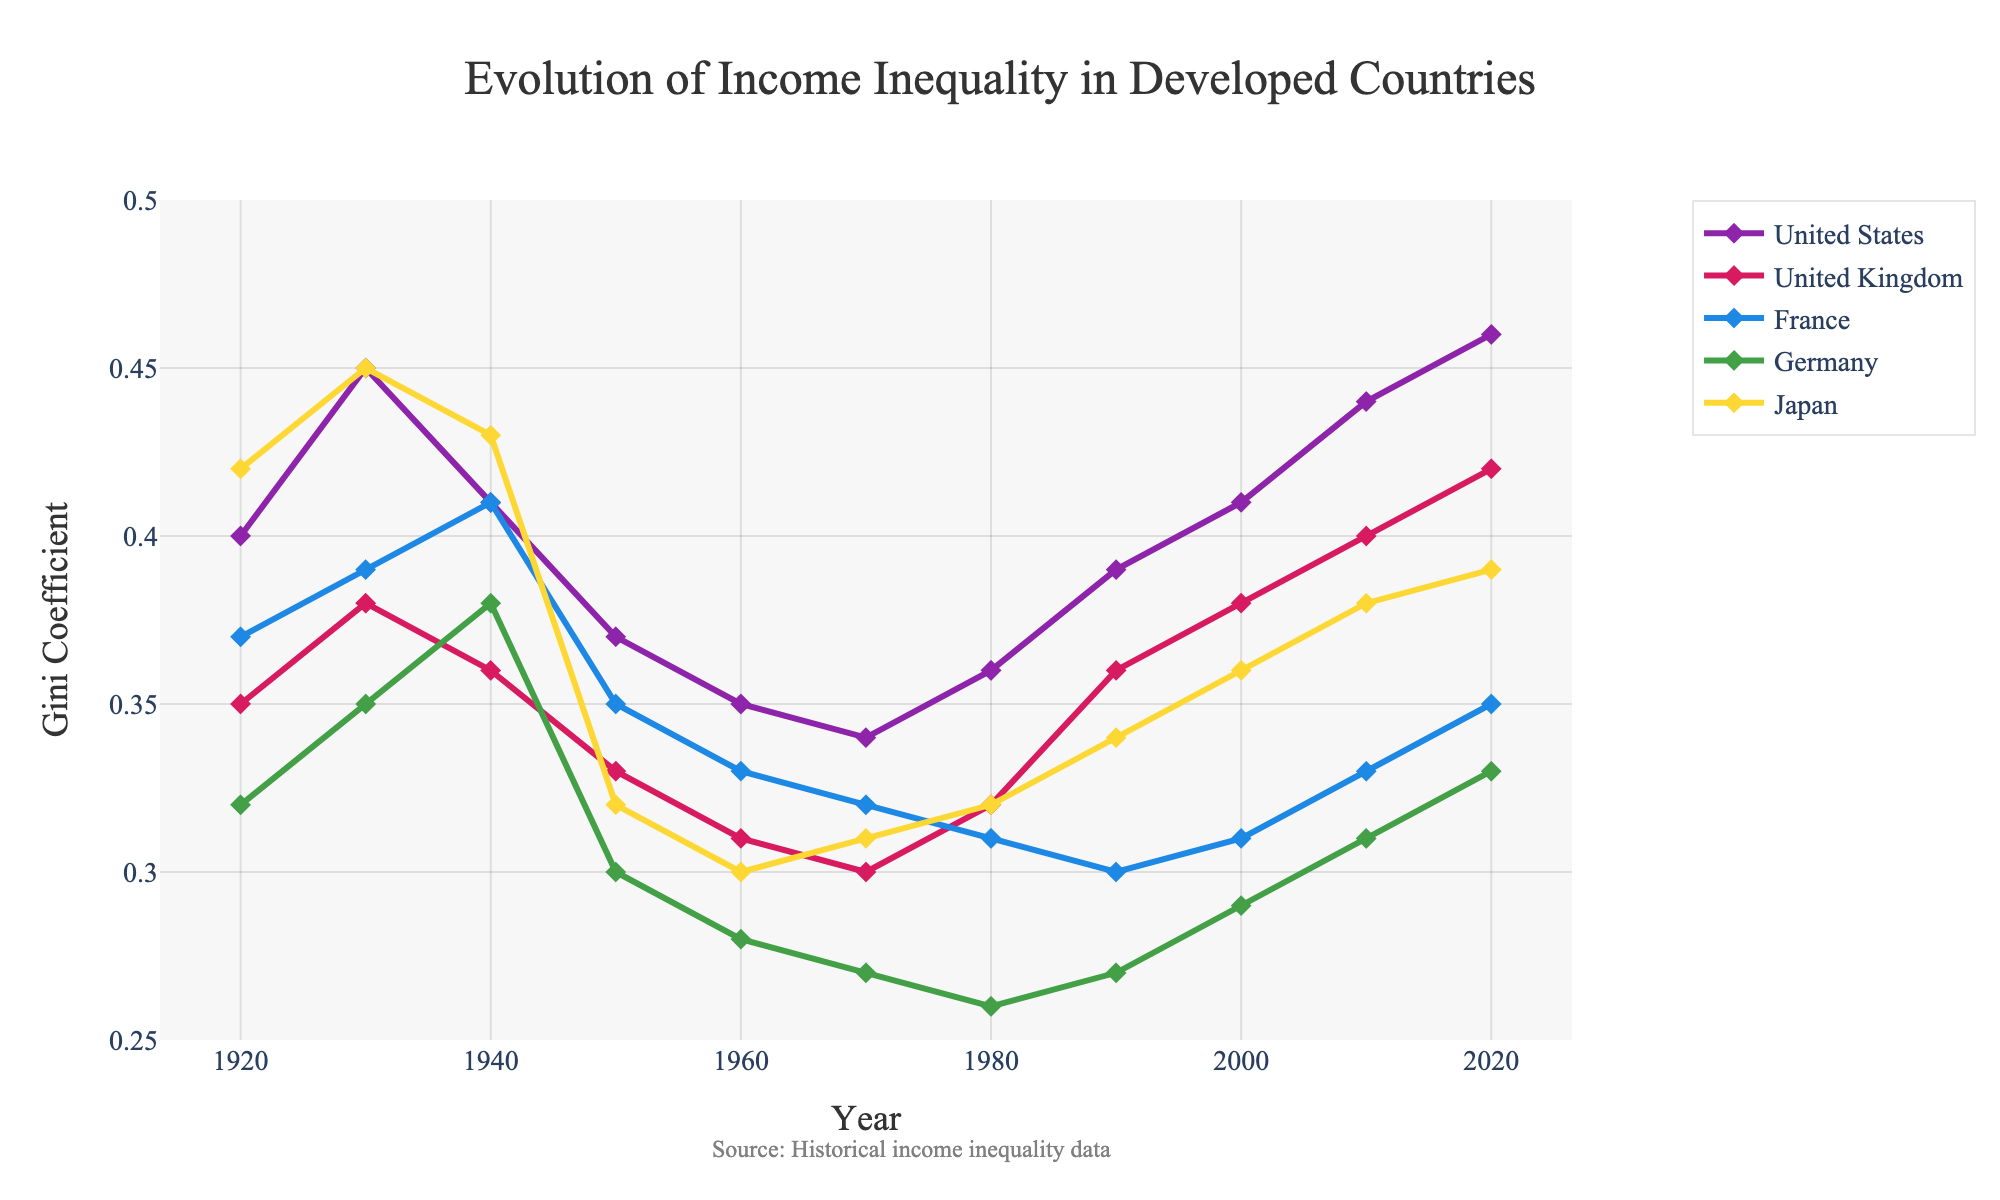what's the country with the highest Gini coefficient in the 1920s? Look for the highest value in the 1920 row. From the provided data, Japan has the highest Gini coefficient of 0.42 in 1920.
Answer: Japan which country showed the largest increase in Gini coefficient from 1950 to 2020? Calculate the difference between 2020 and 1950 for each country. The differences are: United States (+0.09), United Kingdom (+0.09), France (0), Germany (+0.03), Japan (+0.07). Both the United States and the United Kingdom showed the largest increase of 0.09.
Answer: United States and United Kingdom what year did Germany have the lowest Gini coefficient? Look across the Gini coefficient values specific to Germany in all years and identify the lowest one. The lowest value of 0.26 appears in 1980.
Answer: 1980 which country's Gini coefficient stayed the most stable (smallest range) over the century? Calculate the range (max-min) for each country over all years. The ranges are: United States (0.12), United Kingdom (0.12), France (0.11), Germany (0.11), Japan (0.15). France and Germany both have the smallest range of 0.11.
Answer: France and Germany between 1940 and 1950, which country saw the largest drop in Gini coefficient? Calculate the difference between 1940 and 1950 values for each country. The drops are: United States (-0.04), United Kingdom (-0.03), France (-0.06), Germany (-0.08), Japan (-0.11). Japan saw the largest drop of 0.11.
Answer: Japan did any country have a higher Gini coefficient in 1980 compared to 1970? if so, which? Compare the values of 1970 and 1980. Only the United States had a higher Gini coefficient in 1980 (0.36) compared to 1970 (0.34).
Answer: United States which country had the most significant fluctuation in Gini coefficient from 1920 to 2020? To determine the most significant fluctuation, look at the total change from 1920 to 2020, considering both increases and decreases. For all countries: United States (+0.06), United Kingdom (+0.07), France (-0.02), Germany (+0.01), Japan (-0.03). The United Kingdom saw the most significant fluctuation with +0.07.
Answer: United Kingdom what is the average Gini coefficient for France over the entire century? Calculate the average by summing France's values and dividing by the number of data points: (0.37 + 0.39 + 0.41 + 0.35 + 0.33 + 0.32 + 0.31 + 0.30 + 0.31 + 0.33 + 0.35) / 11 = 3.77 / 11 ≈ 0.34.
Answer: 0.34 in which decade did Japan experience the highest increase in Gini coefficient? Calculate the increase for each decade and identify the highest. The increases are: 1920-1930 (+0.03), 1930-1940 (-0.02), 1940-1950 (-0.11), 1950-1960 (-0.02), 1960-1970 (+0.01), 1970-1980 (+0.01), 1980-1990 (+0.02), 1990-2000 (+0.02), 2000-2010 (+0.02), 2010-2020 (+0.01). The largest increase happened in 1920-1930 (+0.03).
Answer: 1920-1930 